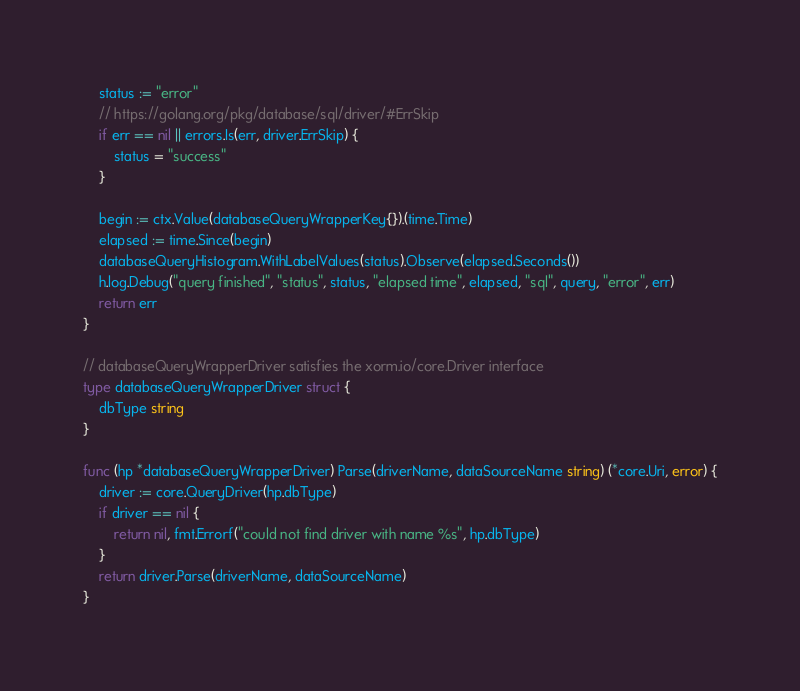Convert code to text. <code><loc_0><loc_0><loc_500><loc_500><_Go_>	status := "error"
	// https://golang.org/pkg/database/sql/driver/#ErrSkip
	if err == nil || errors.Is(err, driver.ErrSkip) {
		status = "success"
	}

	begin := ctx.Value(databaseQueryWrapperKey{}).(time.Time)
	elapsed := time.Since(begin)
	databaseQueryHistogram.WithLabelValues(status).Observe(elapsed.Seconds())
	h.log.Debug("query finished", "status", status, "elapsed time", elapsed, "sql", query, "error", err)
	return err
}

// databaseQueryWrapperDriver satisfies the xorm.io/core.Driver interface
type databaseQueryWrapperDriver struct {
	dbType string
}

func (hp *databaseQueryWrapperDriver) Parse(driverName, dataSourceName string) (*core.Uri, error) {
	driver := core.QueryDriver(hp.dbType)
	if driver == nil {
		return nil, fmt.Errorf("could not find driver with name %s", hp.dbType)
	}
	return driver.Parse(driverName, dataSourceName)
}
</code> 